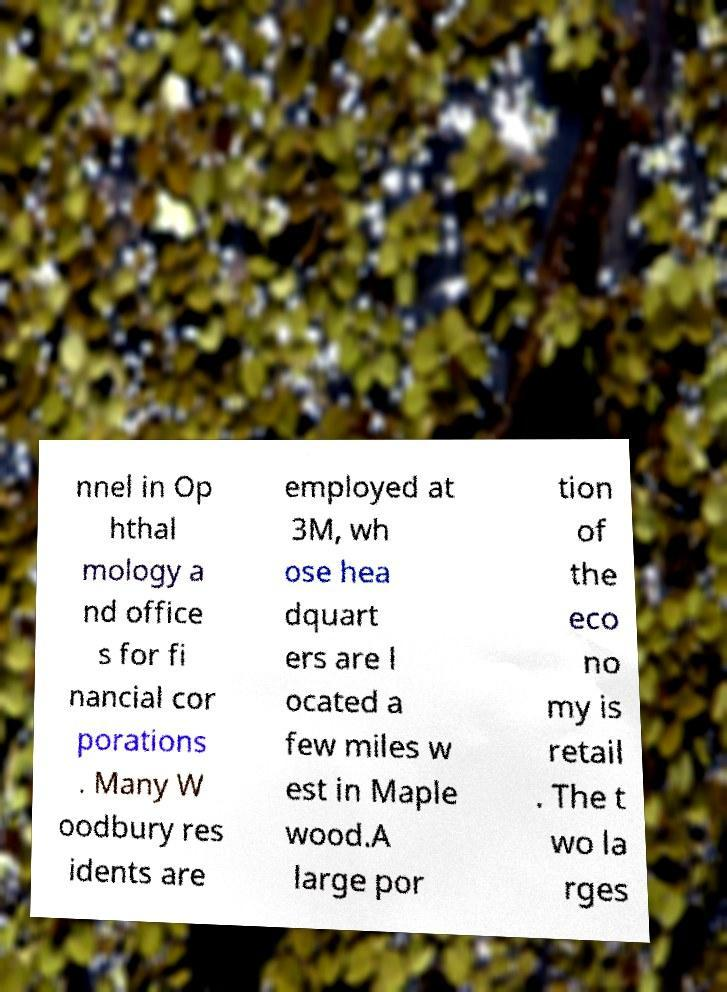Can you read and provide the text displayed in the image?This photo seems to have some interesting text. Can you extract and type it out for me? nnel in Op hthal mology a nd office s for fi nancial cor porations . Many W oodbury res idents are employed at 3M, wh ose hea dquart ers are l ocated a few miles w est in Maple wood.A large por tion of the eco no my is retail . The t wo la rges 